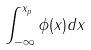<formula> <loc_0><loc_0><loc_500><loc_500>\int _ { - \infty } ^ { x _ { p } } \phi ( x ) d x</formula> 